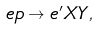Convert formula to latex. <formula><loc_0><loc_0><loc_500><loc_500>e p \rightarrow e ^ { \prime } X Y ,</formula> 